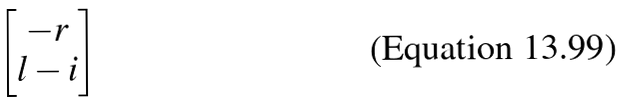<formula> <loc_0><loc_0><loc_500><loc_500>\begin{bmatrix} - r \\ l - i \end{bmatrix}</formula> 